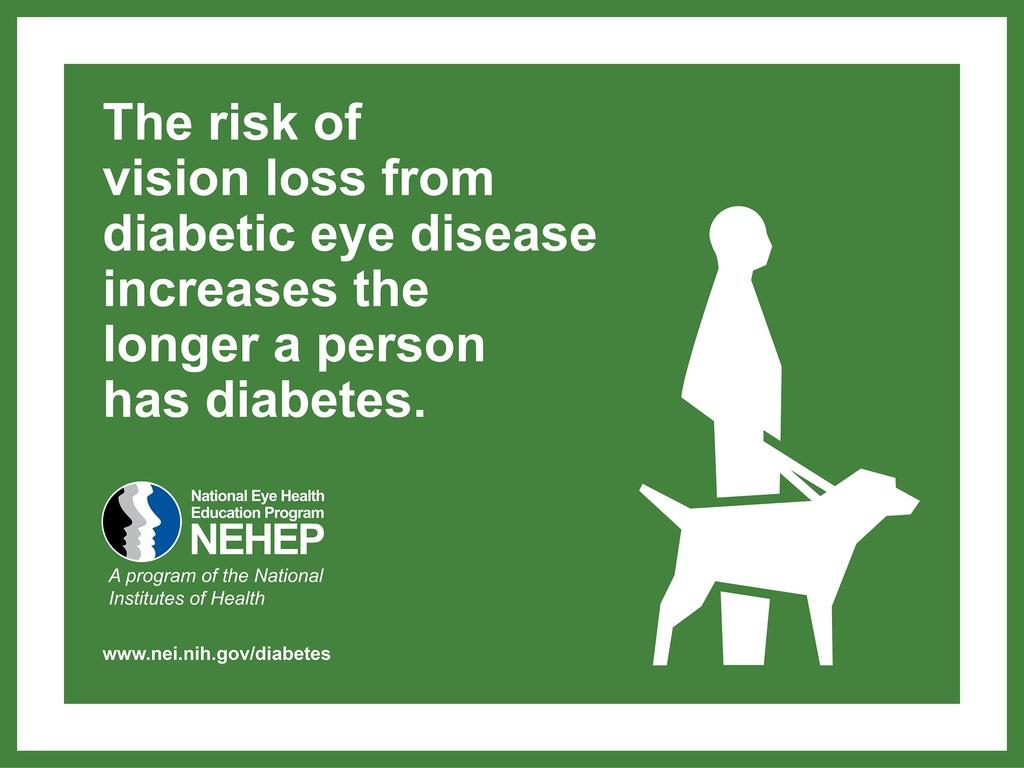What type of visual is the image? The image is a poster. What can be seen on the right side of the poster? There is a person and a dog on the right side of the poster. What is located on the left side of the poster? There is a logo and text on the left side of the poster. What type of pie is being served on the left side of the poster? There is no pie present in the image. 